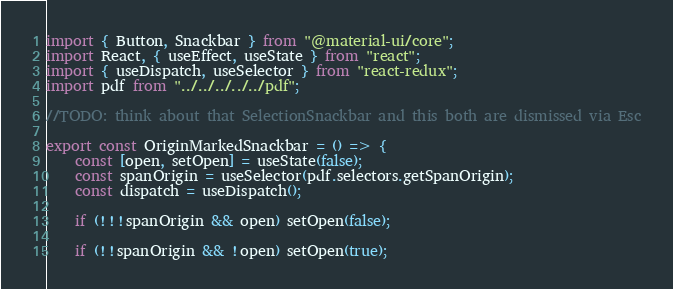Convert code to text. <code><loc_0><loc_0><loc_500><loc_500><_TypeScript_>import { Button, Snackbar } from "@material-ui/core";
import React, { useEffect, useState } from "react";
import { useDispatch, useSelector } from "react-redux";
import pdf from "../../../../../pdf";

//TODO: think about that SelectionSnackbar and this both are dismissed via Esc

export const OriginMarkedSnackbar = () => {
	const [open, setOpen] = useState(false);
	const spanOrigin = useSelector(pdf.selectors.getSpanOrigin);
	const dispatch = useDispatch();

	if (!!!spanOrigin && open) setOpen(false);

	if (!!spanOrigin && !open) setOpen(true);
</code> 